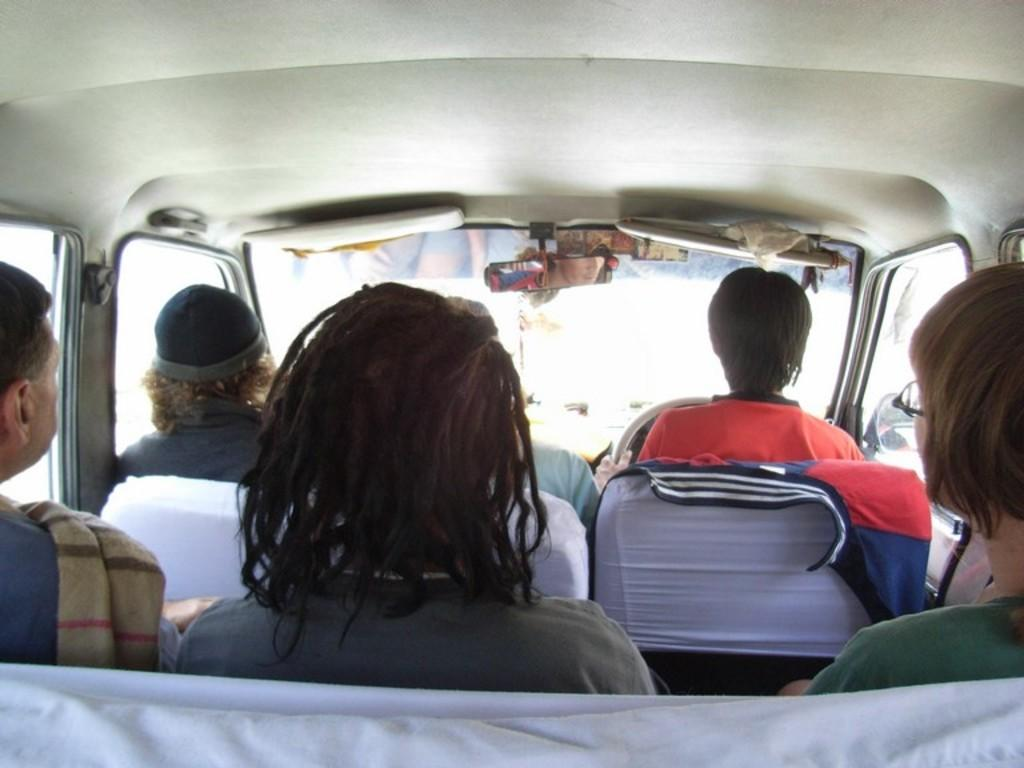What is the main subject of the image? There is a car in the image. Who is operating the car? One person is driving the car. How many people are inside the car? Five people are riding in the car. What else can be seen on the car? There are objects on the car. What type of queen is sitting on the car in the image? There is no queen present in the image; it features a car with people inside and objects on it. Can you see a turkey running alongside the car in the image? There is no turkey present in the image; it only shows a car with people inside and objects on it. 